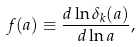<formula> <loc_0><loc_0><loc_500><loc_500>f ( a ) \equiv \frac { d \ln { \delta _ { k } ( a ) } } { d \ln { a } } ,</formula> 